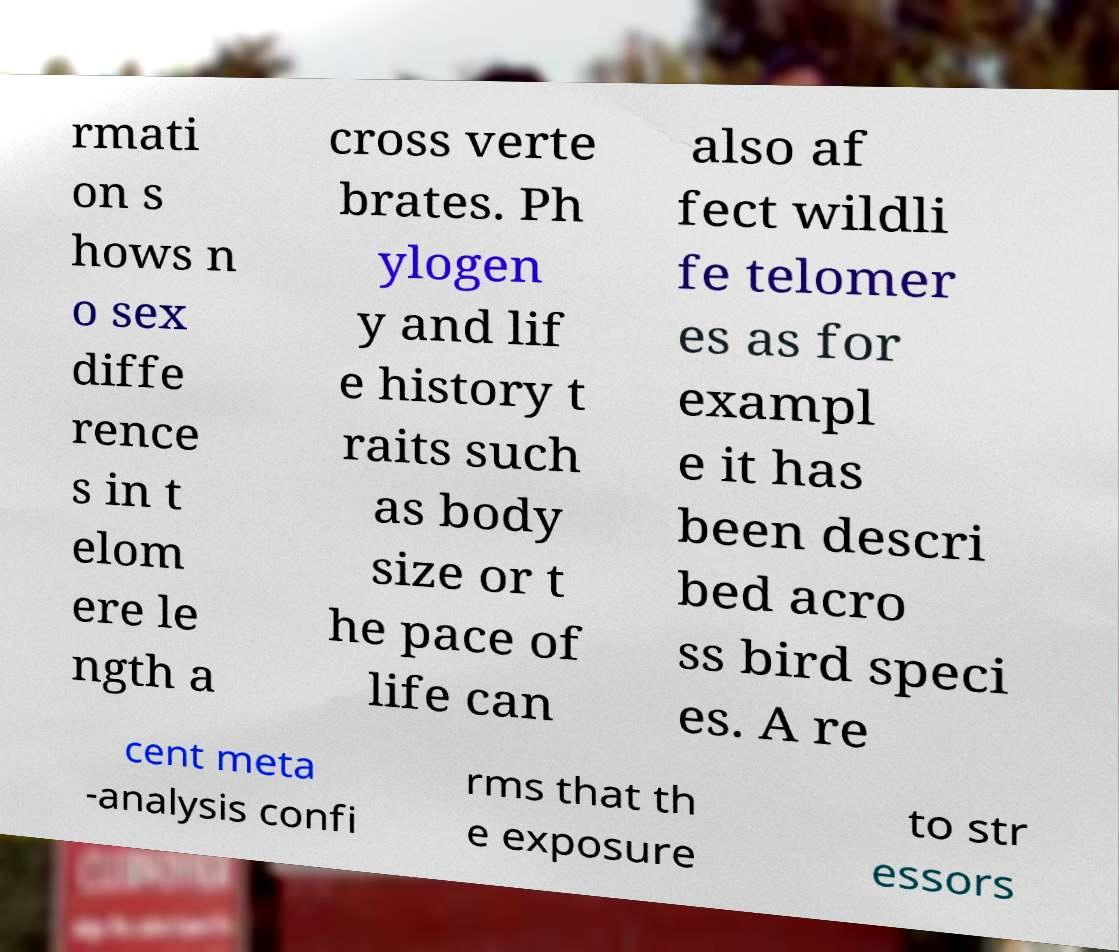Please identify and transcribe the text found in this image. rmati on s hows n o sex diffe rence s in t elom ere le ngth a cross verte brates. Ph ylogen y and lif e history t raits such as body size or t he pace of life can also af fect wildli fe telomer es as for exampl e it has been descri bed acro ss bird speci es. A re cent meta -analysis confi rms that th e exposure to str essors 